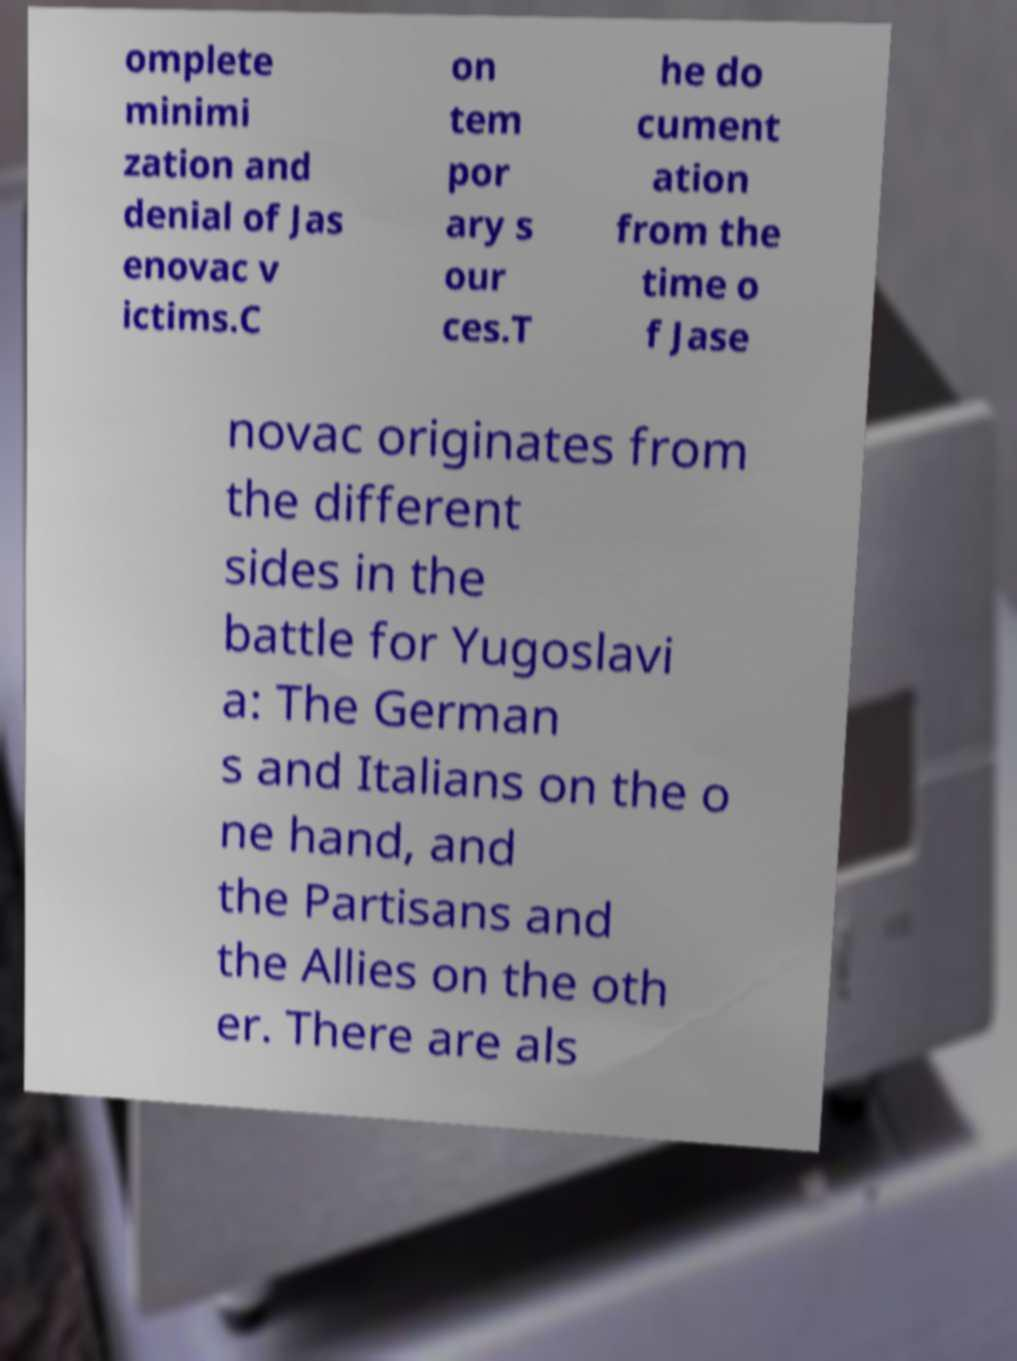Please identify and transcribe the text found in this image. omplete minimi zation and denial of Jas enovac v ictims.C on tem por ary s our ces.T he do cument ation from the time o f Jase novac originates from the different sides in the battle for Yugoslavi a: The German s and Italians on the o ne hand, and the Partisans and the Allies on the oth er. There are als 